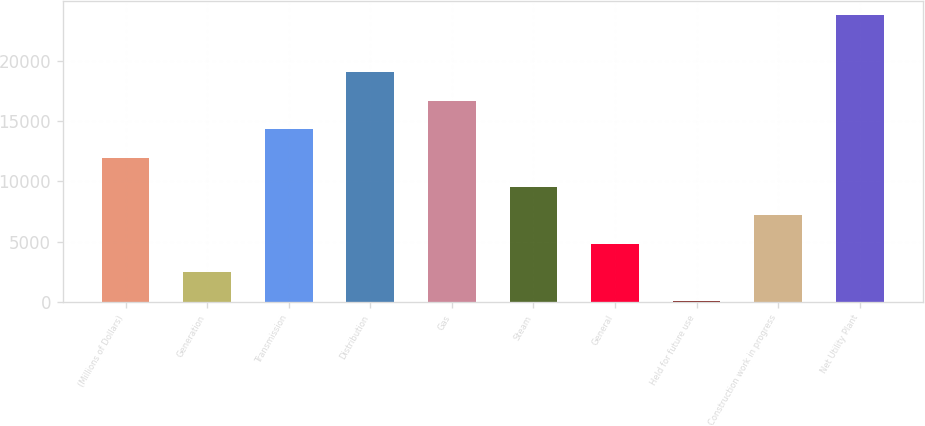<chart> <loc_0><loc_0><loc_500><loc_500><bar_chart><fcel>(Millions of Dollars)<fcel>Generation<fcel>Transmission<fcel>Distribution<fcel>Gas<fcel>Steam<fcel>General<fcel>Held for future use<fcel>Construction work in progress<fcel>Net Utility Plant<nl><fcel>11933<fcel>2444.2<fcel>14305.2<fcel>19049.6<fcel>16677.4<fcel>9560.8<fcel>4816.4<fcel>72<fcel>7188.6<fcel>23794<nl></chart> 